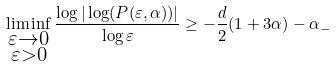<formula> <loc_0><loc_0><loc_500><loc_500>\liminf _ { \substack { \varepsilon \to 0 \\ \varepsilon > 0 } } \frac { \log | \log ( P ( \varepsilon , \alpha ) ) | } { \log \varepsilon } \geq - \frac { d } { 2 } ( 1 + 3 \alpha ) - \alpha _ { - }</formula> 